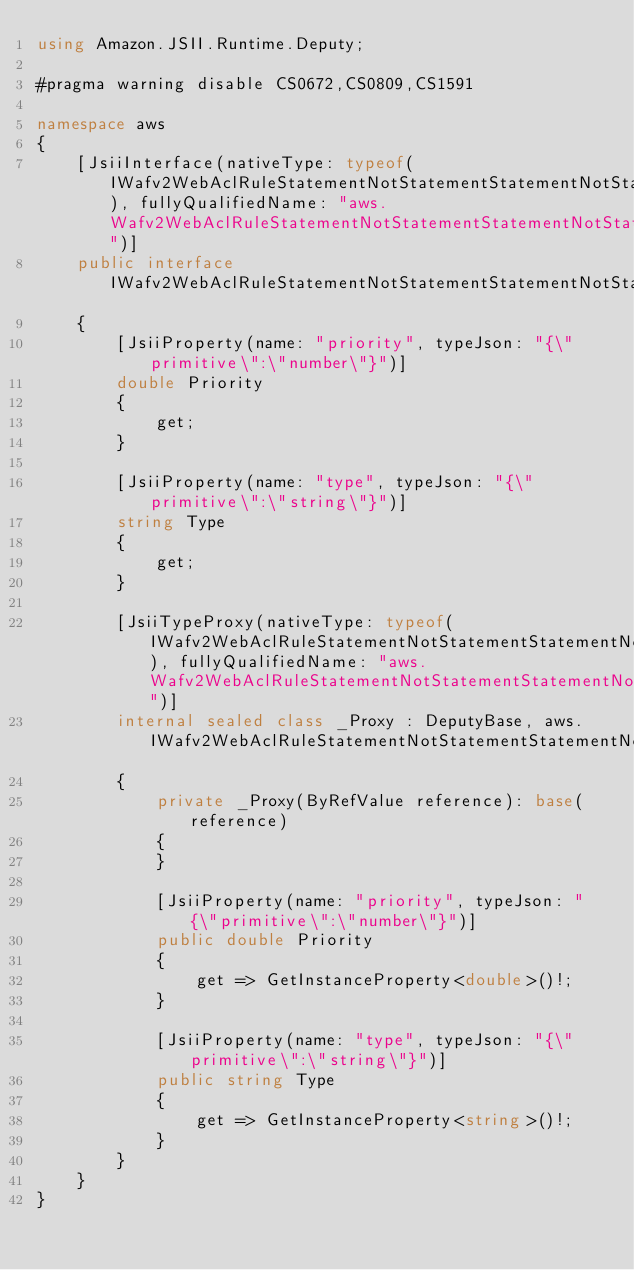<code> <loc_0><loc_0><loc_500><loc_500><_C#_>using Amazon.JSII.Runtime.Deputy;

#pragma warning disable CS0672,CS0809,CS1591

namespace aws
{
    [JsiiInterface(nativeType: typeof(IWafv2WebAclRuleStatementNotStatementStatementNotStatementStatementSizeConstraintStatementTextTransformation), fullyQualifiedName: "aws.Wafv2WebAclRuleStatementNotStatementStatementNotStatementStatementSizeConstraintStatementTextTransformation")]
    public interface IWafv2WebAclRuleStatementNotStatementStatementNotStatementStatementSizeConstraintStatementTextTransformation
    {
        [JsiiProperty(name: "priority", typeJson: "{\"primitive\":\"number\"}")]
        double Priority
        {
            get;
        }

        [JsiiProperty(name: "type", typeJson: "{\"primitive\":\"string\"}")]
        string Type
        {
            get;
        }

        [JsiiTypeProxy(nativeType: typeof(IWafv2WebAclRuleStatementNotStatementStatementNotStatementStatementSizeConstraintStatementTextTransformation), fullyQualifiedName: "aws.Wafv2WebAclRuleStatementNotStatementStatementNotStatementStatementSizeConstraintStatementTextTransformation")]
        internal sealed class _Proxy : DeputyBase, aws.IWafv2WebAclRuleStatementNotStatementStatementNotStatementStatementSizeConstraintStatementTextTransformation
        {
            private _Proxy(ByRefValue reference): base(reference)
            {
            }

            [JsiiProperty(name: "priority", typeJson: "{\"primitive\":\"number\"}")]
            public double Priority
            {
                get => GetInstanceProperty<double>()!;
            }

            [JsiiProperty(name: "type", typeJson: "{\"primitive\":\"string\"}")]
            public string Type
            {
                get => GetInstanceProperty<string>()!;
            }
        }
    }
}
</code> 